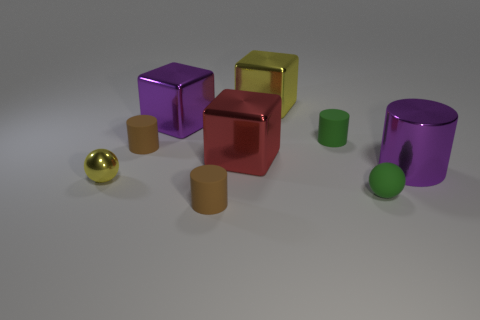How many purple objects are either big metallic things or small spheres?
Ensure brevity in your answer.  2. Are there more large cylinders than green objects?
Your answer should be very brief. No. How many objects are tiny objects that are behind the tiny rubber ball or yellow metal objects in front of the small green cylinder?
Offer a terse response. 3. What is the color of the cylinder that is the same size as the yellow metallic block?
Provide a short and direct response. Purple. Is the large yellow object made of the same material as the purple block?
Provide a succinct answer. Yes. What is the material of the cylinder in front of the tiny sphere that is on the right side of the large yellow block?
Offer a very short reply. Rubber. Are there more purple cubes to the right of the purple metallic cylinder than blue objects?
Your response must be concise. No. How many other objects are there of the same size as the red metallic thing?
Ensure brevity in your answer.  3. Is the large shiny cylinder the same color as the tiny metal sphere?
Offer a very short reply. No. There is a matte cylinder that is left of the rubber cylinder that is in front of the ball that is on the left side of the big purple block; what is its color?
Offer a very short reply. Brown. 